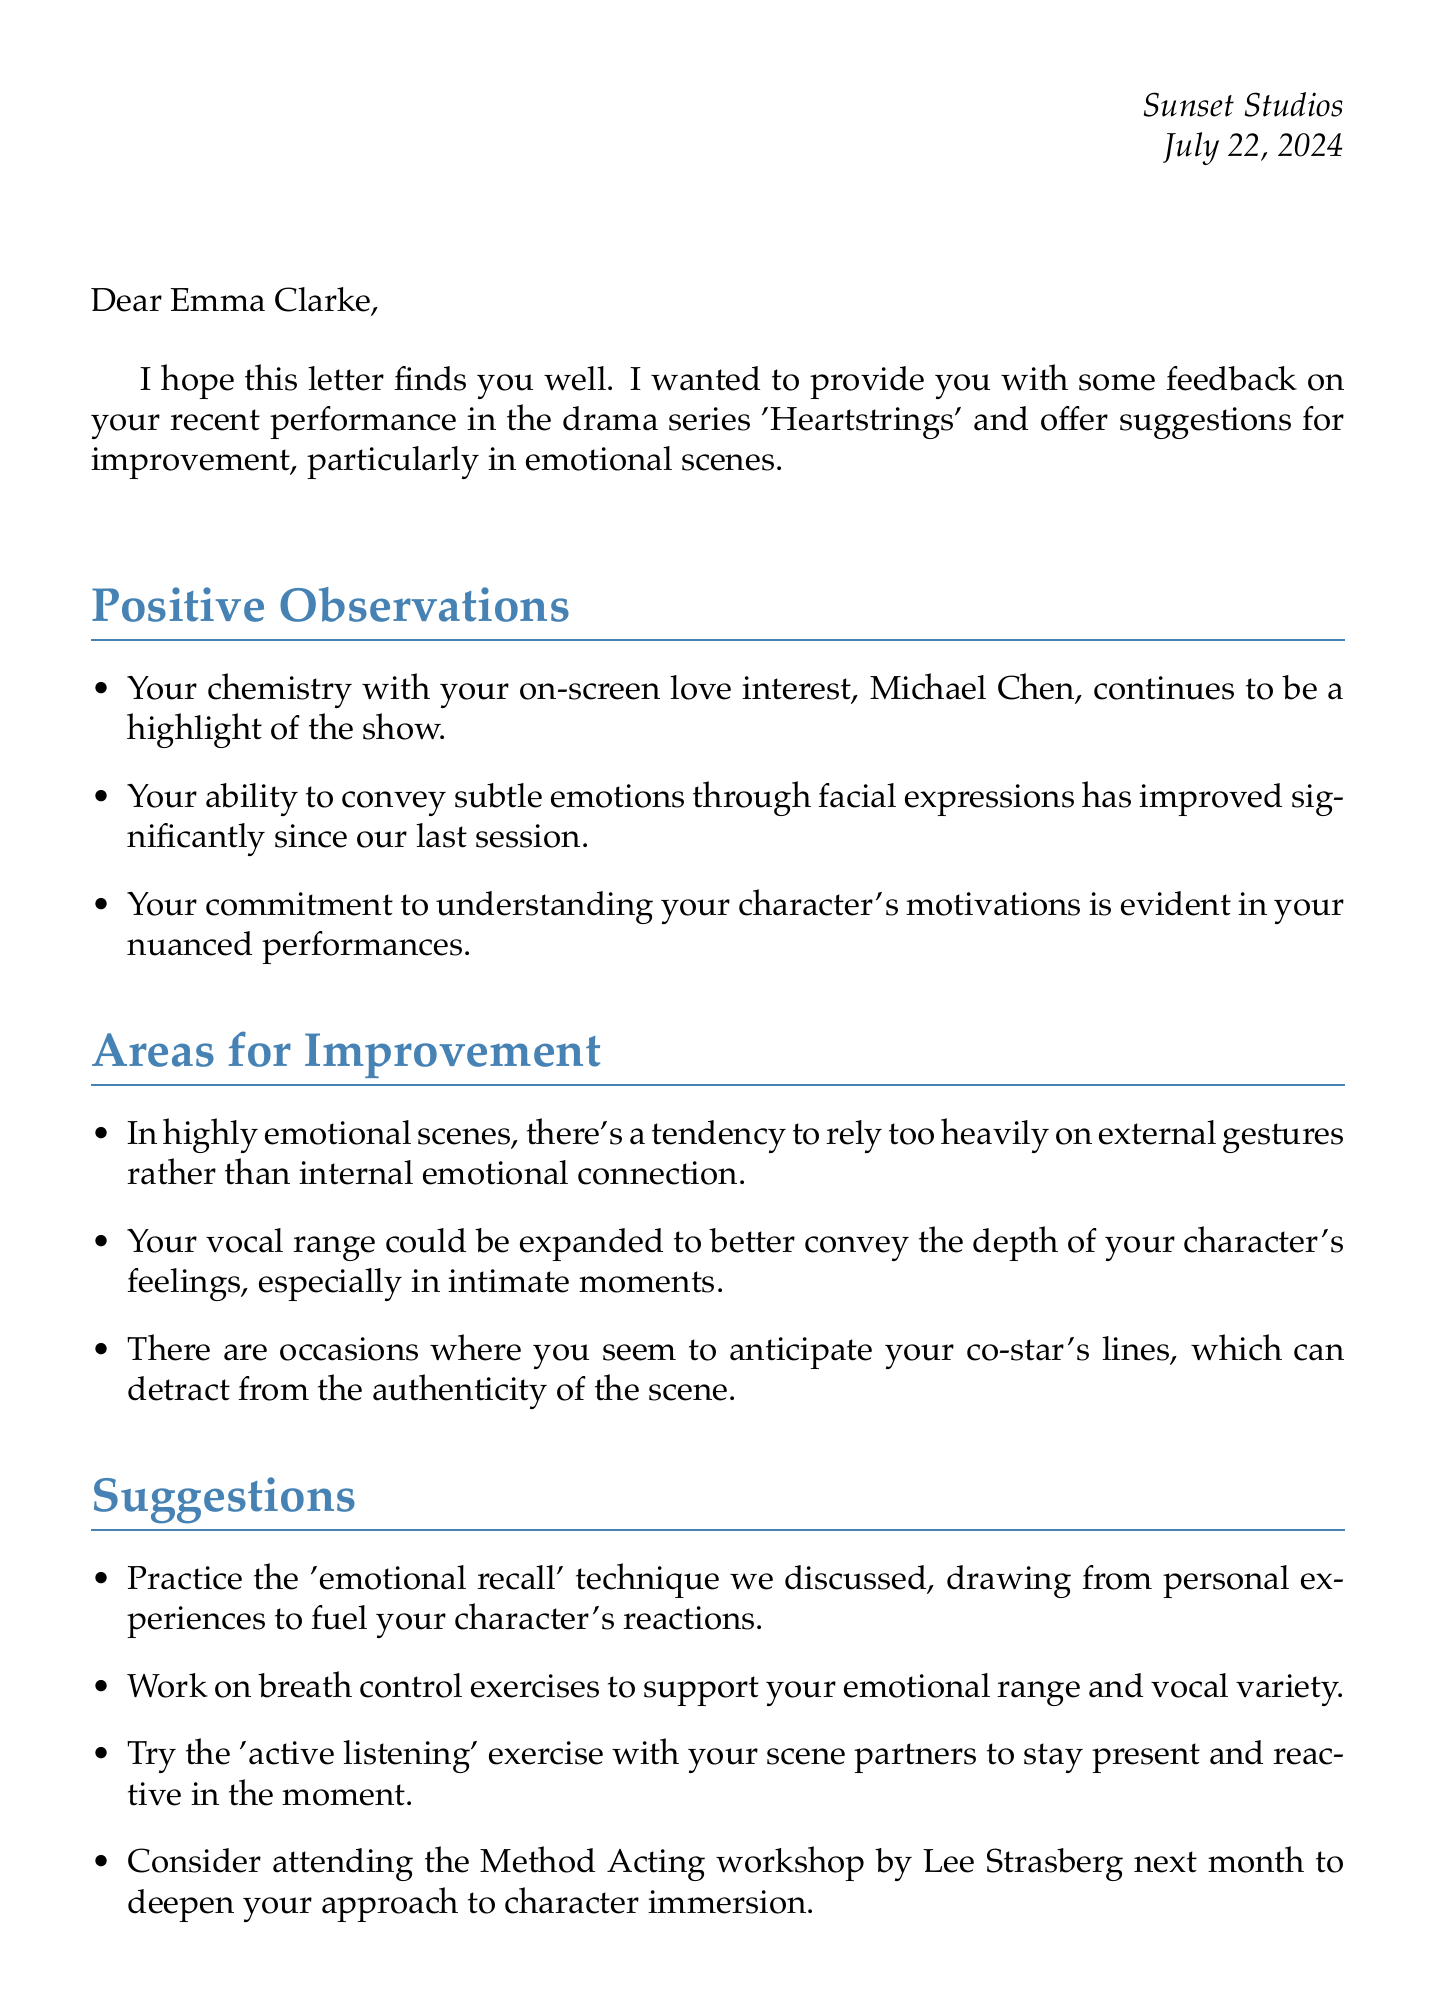What is the name of the actress? The letter specifically addresses the actress by name at the beginning.
Answer: Emma Clarke Who is the on-screen love interest of the actress? The positive observations mention the actress's chemistry with her co-star providing their name.
Answer: Michael Chen What is the title of the upcoming episode mentioned? The upcoming challenges section refers to a specific episode title.
Answer: Shattered Promises Who is the acting coach? The signature at the end of the letter reveals the name of the coach.
Answer: Olivia Rodriguez What technique should the actress practice according to the suggestions? One of the suggestions explicitly mentions a specific acting technique aimed at enhancing emotional performance.
Answer: emotional recall What is one area of improvement mentioned for emotional scenes? The document lists specific areas where the actress can improve her performance.
Answer: reliance on external gestures How many days is the Method Acting workshop scheduled for? The letter mentions the duration of the workshop in days for clarity.
Answer: 3 What should the actress research for the potential character arc? The upcoming challenges provide insight into what the actress should focus on for future preparation.
Answer: addiction 